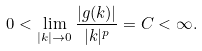Convert formula to latex. <formula><loc_0><loc_0><loc_500><loc_500>0 < \lim _ { | k | \rightarrow 0 } \frac { | g ( k ) | } { | k | ^ { p } } = C < \infty .</formula> 